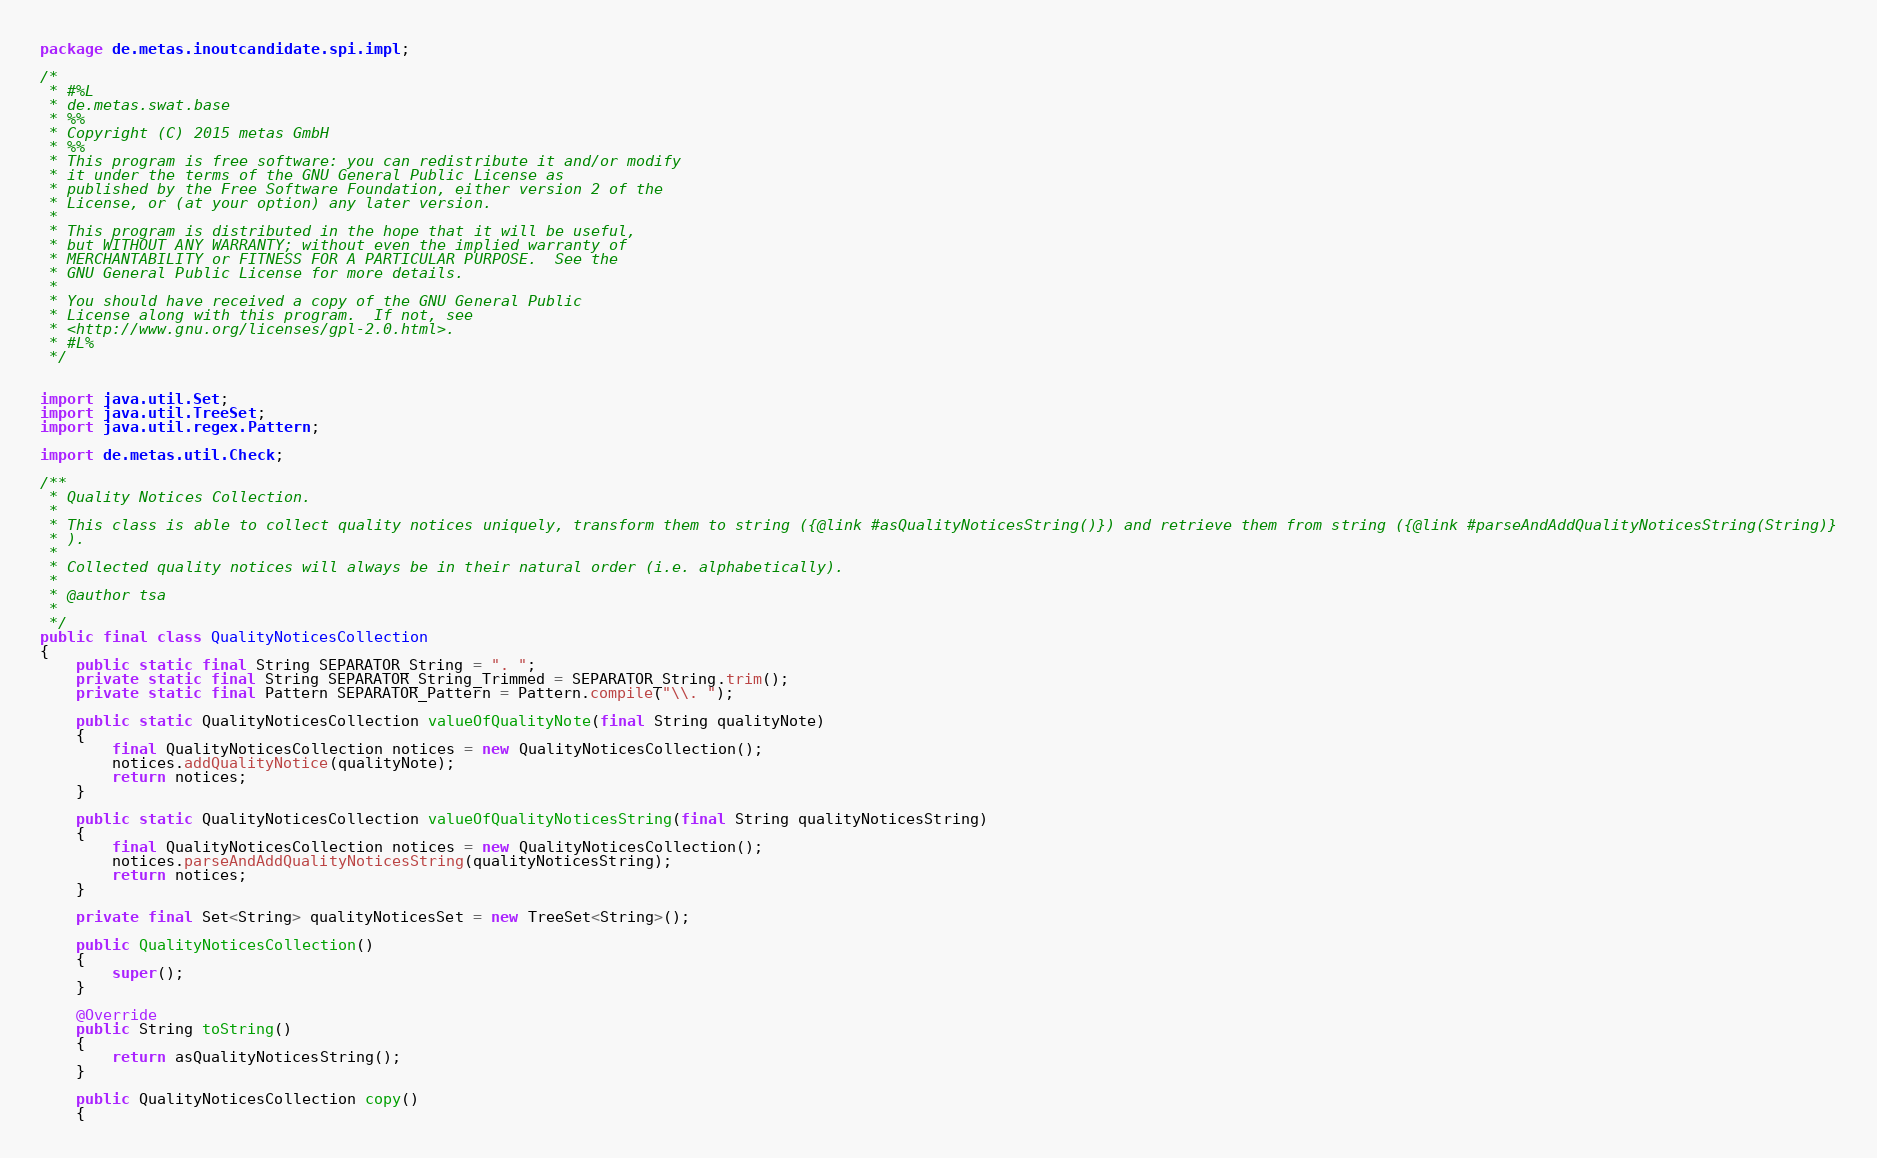Convert code to text. <code><loc_0><loc_0><loc_500><loc_500><_Java_>package de.metas.inoutcandidate.spi.impl;

/*
 * #%L
 * de.metas.swat.base
 * %%
 * Copyright (C) 2015 metas GmbH
 * %%
 * This program is free software: you can redistribute it and/or modify
 * it under the terms of the GNU General Public License as
 * published by the Free Software Foundation, either version 2 of the
 * License, or (at your option) any later version.
 * 
 * This program is distributed in the hope that it will be useful,
 * but WITHOUT ANY WARRANTY; without even the implied warranty of
 * MERCHANTABILITY or FITNESS FOR A PARTICULAR PURPOSE.  See the
 * GNU General Public License for more details.
 * 
 * You should have received a copy of the GNU General Public
 * License along with this program.  If not, see
 * <http://www.gnu.org/licenses/gpl-2.0.html>.
 * #L%
 */


import java.util.Set;
import java.util.TreeSet;
import java.util.regex.Pattern;

import de.metas.util.Check;

/**
 * Quality Notices Collection.
 *
 * This class is able to collect quality notices uniquely, transform them to string ({@link #asQualityNoticesString()}) and retrieve them from string ({@link #parseAndAddQualityNoticesString(String)}
 * ).
 *
 * Collected quality notices will always be in their natural order (i.e. alphabetically).
 *
 * @author tsa
 *
 */
public final class QualityNoticesCollection
{
	public static final String SEPARATOR_String = ". ";
	private static final String SEPARATOR_String_Trimmed = SEPARATOR_String.trim();
	private static final Pattern SEPARATOR_Pattern = Pattern.compile("\\. ");

	public static QualityNoticesCollection valueOfQualityNote(final String qualityNote)
	{
		final QualityNoticesCollection notices = new QualityNoticesCollection();
		notices.addQualityNotice(qualityNote);
		return notices;
	}

	public static QualityNoticesCollection valueOfQualityNoticesString(final String qualityNoticesString)
	{
		final QualityNoticesCollection notices = new QualityNoticesCollection();
		notices.parseAndAddQualityNoticesString(qualityNoticesString);
		return notices;
	}

	private final Set<String> qualityNoticesSet = new TreeSet<String>();

	public QualityNoticesCollection()
	{
		super();
	}

	@Override
	public String toString()
	{
		return asQualityNoticesString();
	}

	public QualityNoticesCollection copy()
	{</code> 